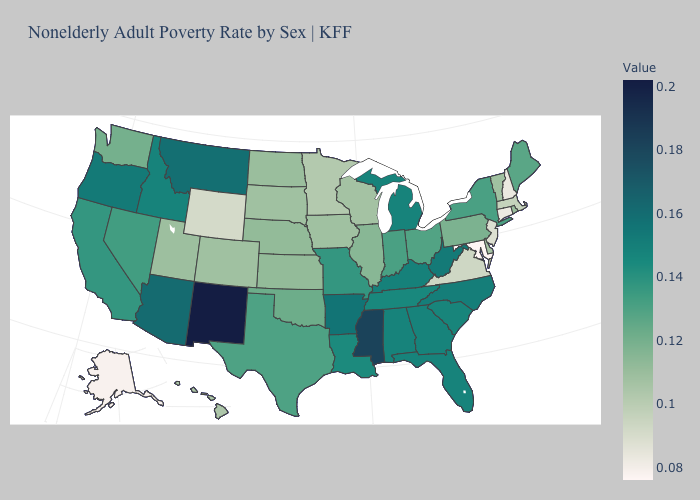Which states have the lowest value in the USA?
Keep it brief. Maryland. Among the states that border Florida , which have the highest value?
Give a very brief answer. Alabama, Georgia. 